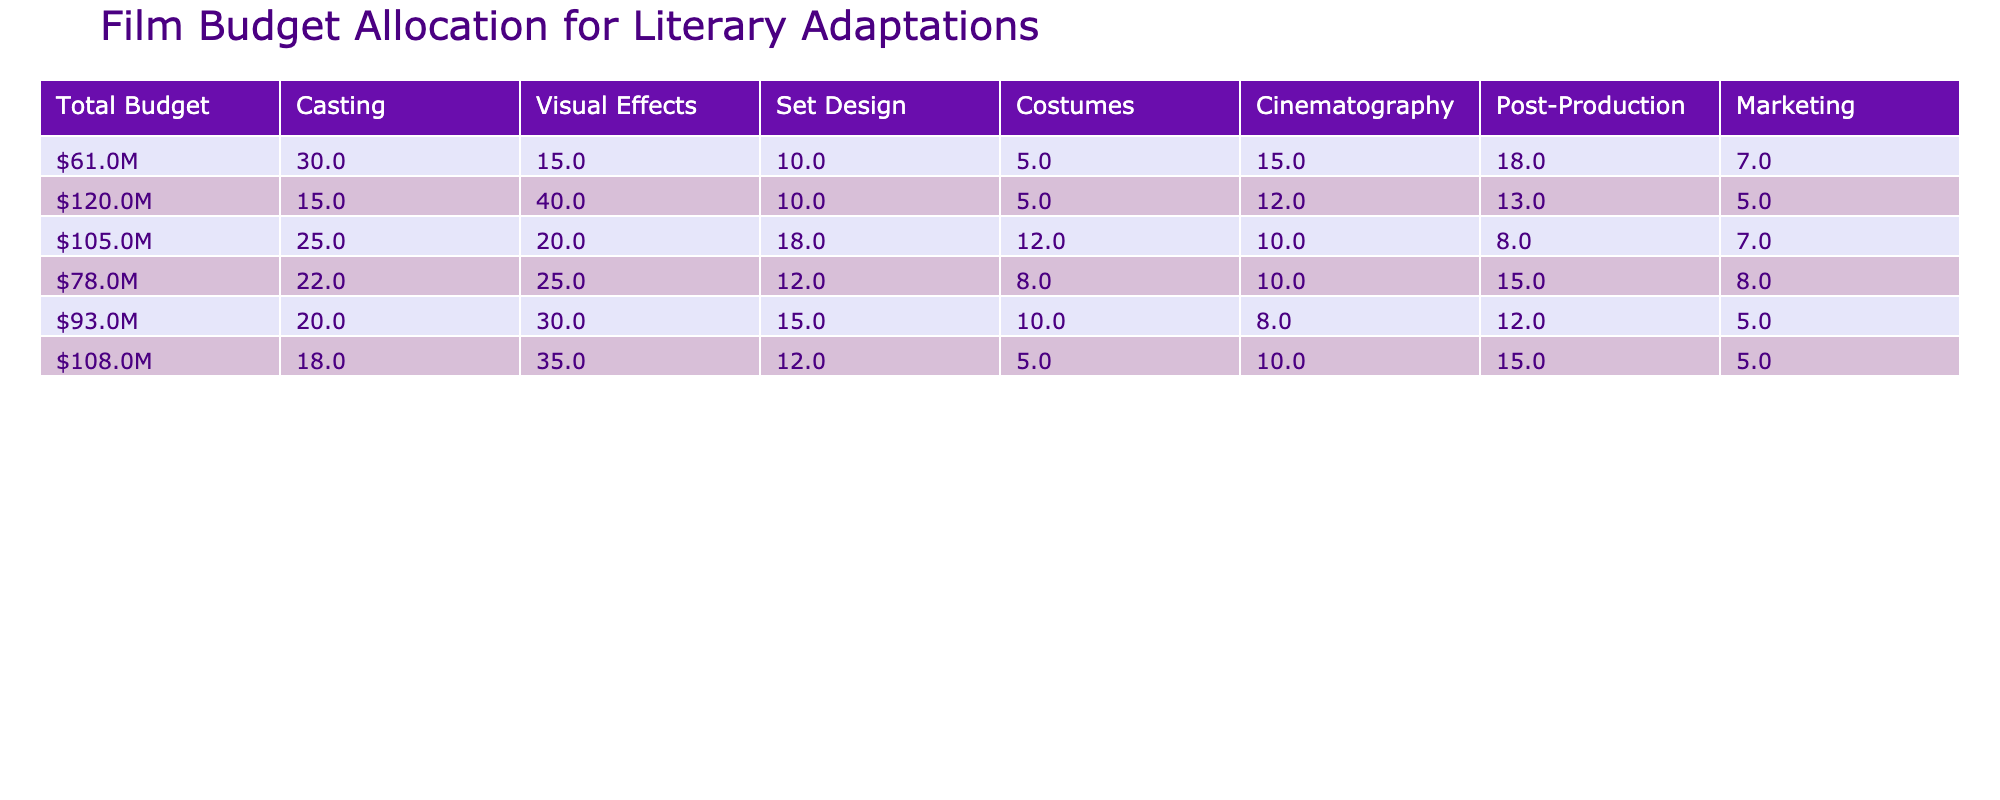What is the total budget for "Life of Pi"? The table shows that "Life of Pi" has a total budget listed under the Total Budget column, which is $120M.
Answer: $120M Which film allocated the highest percentage to Visual Effects? By comparing the Visual Effects percentages for each film, "Life of Pi" has the highest allocation at 40%.
Answer: Life of Pi What is the combined percentage allocation for Casting in "The Lord of the Rings: The Fellowship of the Ring" and "The Hunger Games"? The Casting percentages are 20% for "The Lord of the Rings: The Fellowship of the Ring" and 22% for "The Hunger Games". Added together, they sum to 20% + 22% = 42%.
Answer: 42% Did "Gone Girl" have a higher percentage allocated to Marketing compared to "The Great Gatsby"? "Gone Girl" allocated 7% to Marketing while "The Great Gatsby" allocated 7% as well. Since both percentages are the same, the answer is no, it is not higher.
Answer: No What is the difference in budget allocation for Set Design between "The Great Gatsby" and "The Martian"? The Set Design percentage for "The Great Gatsby" is 18% and for "The Martian", it is 12%. The difference is calculated as 18% - 12% = 6%.
Answer: 6% Which film had the lowest percentage allocated to Costumes? The table indicates that "Life of Pi" allocated only 5% to Costumes, which is the lowest compared to the other films listed.
Answer: Life of Pi What is the average budget allocation percentage for Post-Production across all films? To find the average for Post-Production, we sum all the Post-Production percentages: (12 + 8 + 13 + 15 + 18 + 15 + 5) = 87%. There are 7 films, so the average is 87% / 7 = 12.43%, which rounds to approximately 12.4%.
Answer: 12.4% Is it true that the Casting allocation for "Gone Girl" is equal to the Marketing allocation for "The Hunger Games"? "Gone Girl" has a Casting allocation of 30%, while "The Hunger Games" has a Marketing allocation of 8%. Since both percentages differ, the statement is false.
Answer: No 